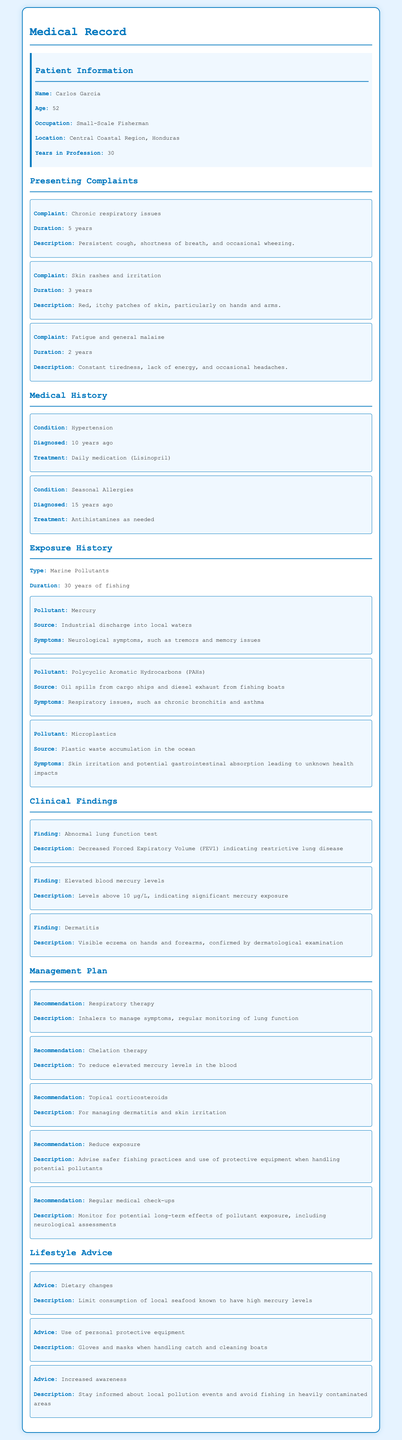What is the patient's name? The patient's name is presented in the "Patient Information" section of the document.
Answer: Carlos Garcia How many years has Carlos been in the fishing profession? The document states that Carlos has worked as a fisherman for 30 years.
Answer: 30 years What pollutants has Carlos been exposed to? The document lists specific pollutants in the "Exposure History" section.
Answer: Mercury, PAHs, Microplastics What is one of Carlos's presenting complaints? The "Presenting Complaints" section includes multiple complaints; one example can be taken from it.
Answer: Chronic respiratory issues What treatment is recommended for Carlos's dermatitis? The "Management Plan" outlines recommendations for dermatitis treatment.
Answer: Topical corticosteroids What is Carlos's age? The age of the patient is mentioned in the "Patient Information" section.
Answer: 52 How are Carlos's lung functions described? The findings regarding lung function are detailed under "Clinical Findings."
Answer: Decreased Forced Expiratory Volume (FEV1) What is the source of mercury exposure for Carlos? The source of exposure is provided in the "Exposure History" section of the document.
Answer: Industrial discharge into local waters What dietary change is advised for Carlos? The "Lifestyle Advice" section includes specific dietary recommendations for Carlos.
Answer: Limit consumption of local seafood known to have high mercury levels 